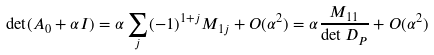<formula> <loc_0><loc_0><loc_500><loc_500>\det ( A _ { 0 } + \alpha I ) = \alpha \sum _ { j } ( - 1 ) ^ { 1 + j } M _ { 1 j } + O ( \alpha ^ { 2 } ) = \alpha \frac { M _ { 1 1 } } { \det D _ { P } } + O ( \alpha ^ { 2 } )</formula> 